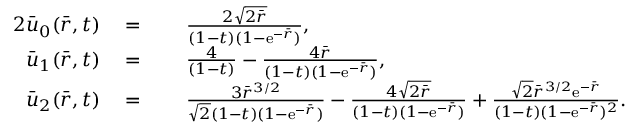<formula> <loc_0><loc_0><loc_500><loc_500>\begin{array} { r l r l } { { 2 } \bar { u } _ { 0 } ( \bar { r } , t ) } & { \, = } & & { \, \frac { 2 \sqrt { 2 \bar { r } } } { ( 1 - t ) ( 1 - e ^ { - \bar { r } } ) } , } \\ { \bar { u } _ { 1 } ( \bar { r } , t ) } & { \, = } & & { \, \frac { 4 } { ( 1 - t ) } - \frac { 4 \bar { r } } { ( 1 - t ) ( 1 - e ^ { - \bar { r } } ) } , } \\ { \bar { u } _ { 2 } ( \bar { r } , t ) } & { \, = } & & { \, \frac { 3 \bar { r } ^ { 3 / 2 } } { \sqrt { 2 } ( 1 - t ) ( 1 - e ^ { - \bar { r } } ) } - \frac { 4 \sqrt { 2 \bar { r } } } { ( 1 - t ) ( 1 - e ^ { - \bar { r } } ) } + \frac { \sqrt { 2 } \bar { r } ^ { 3 / 2 } e ^ { - \bar { r } } } { ( 1 - t ) ( 1 - e ^ { - \bar { r } } ) ^ { 2 } } . } \end{array}</formula> 